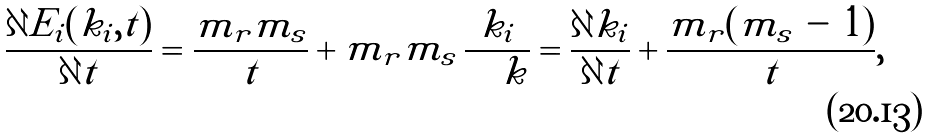Convert formula to latex. <formula><loc_0><loc_0><loc_500><loc_500>\frac { \partial E _ { i } ( k _ { i } , t ) } { \partial t } = \frac { m _ { r } m _ { s } } { t } + m _ { r } m _ { s } \, \frac { k _ { i } } { \sum k } = \frac { \partial k _ { i } } { \partial t } + \frac { m _ { r } ( m _ { s } \, - \, 1 ) } { t } ,</formula> 